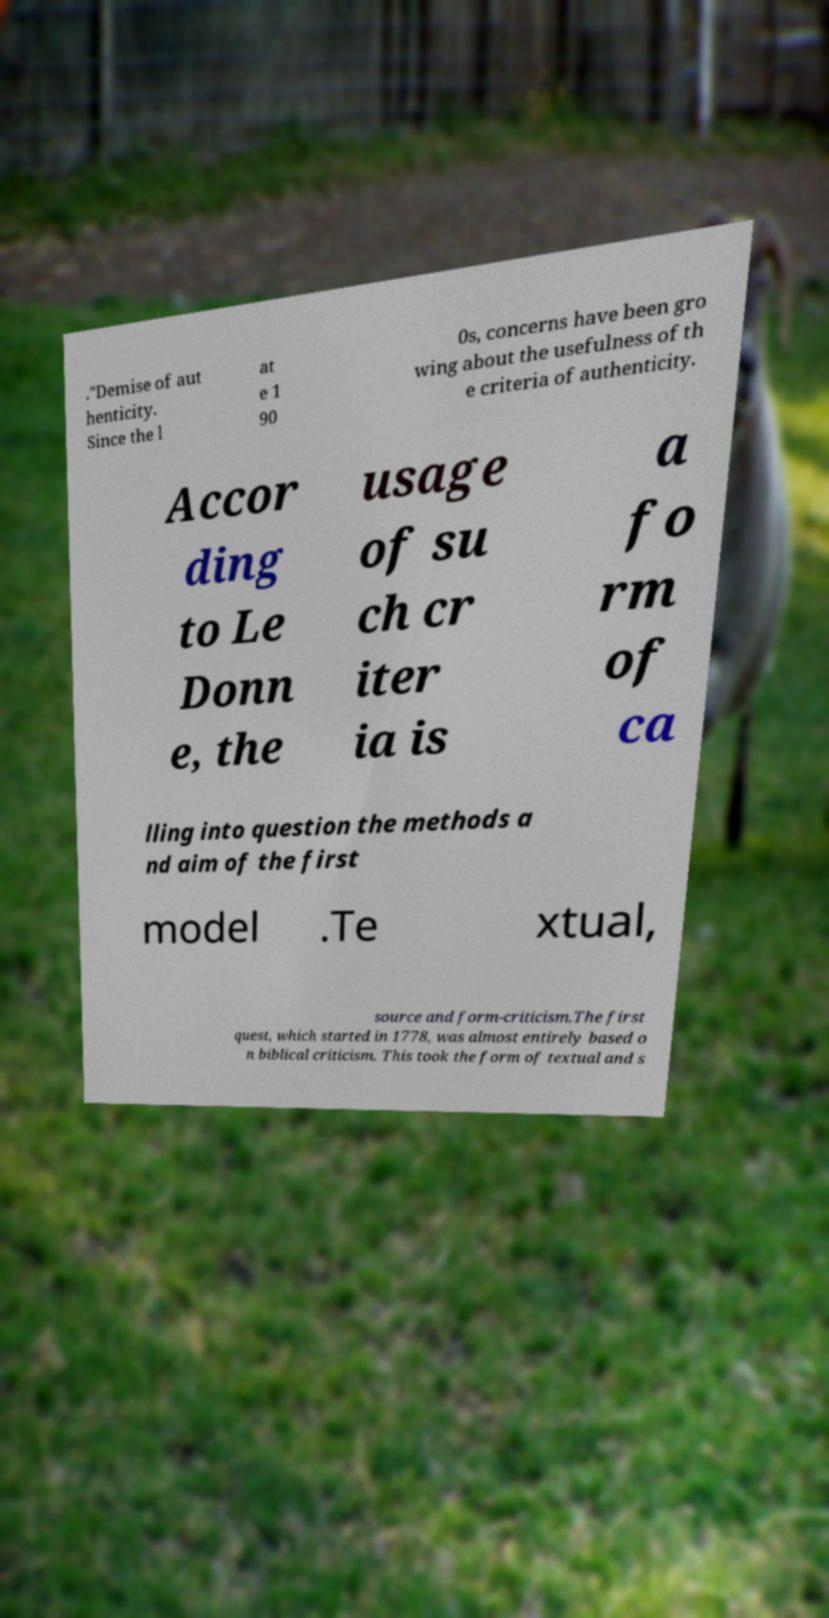For documentation purposes, I need the text within this image transcribed. Could you provide that? ."Demise of aut henticity. Since the l at e 1 90 0s, concerns have been gro wing about the usefulness of th e criteria of authenticity. Accor ding to Le Donn e, the usage of su ch cr iter ia is a fo rm of ca lling into question the methods a nd aim of the first model .Te xtual, source and form-criticism.The first quest, which started in 1778, was almost entirely based o n biblical criticism. This took the form of textual and s 